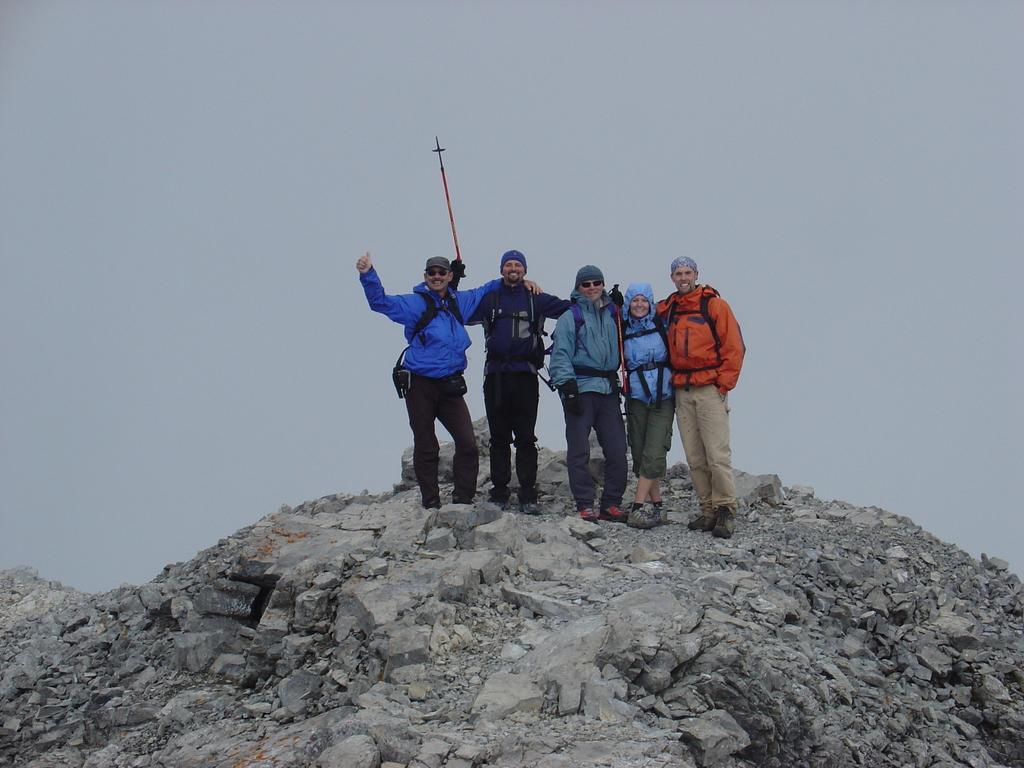How would you summarize this image in a sentence or two? In this image I can see five persons wearing jackets, pants and caps are standing on the rock mountain which is black and ash in color. In the background I can see the sky. 